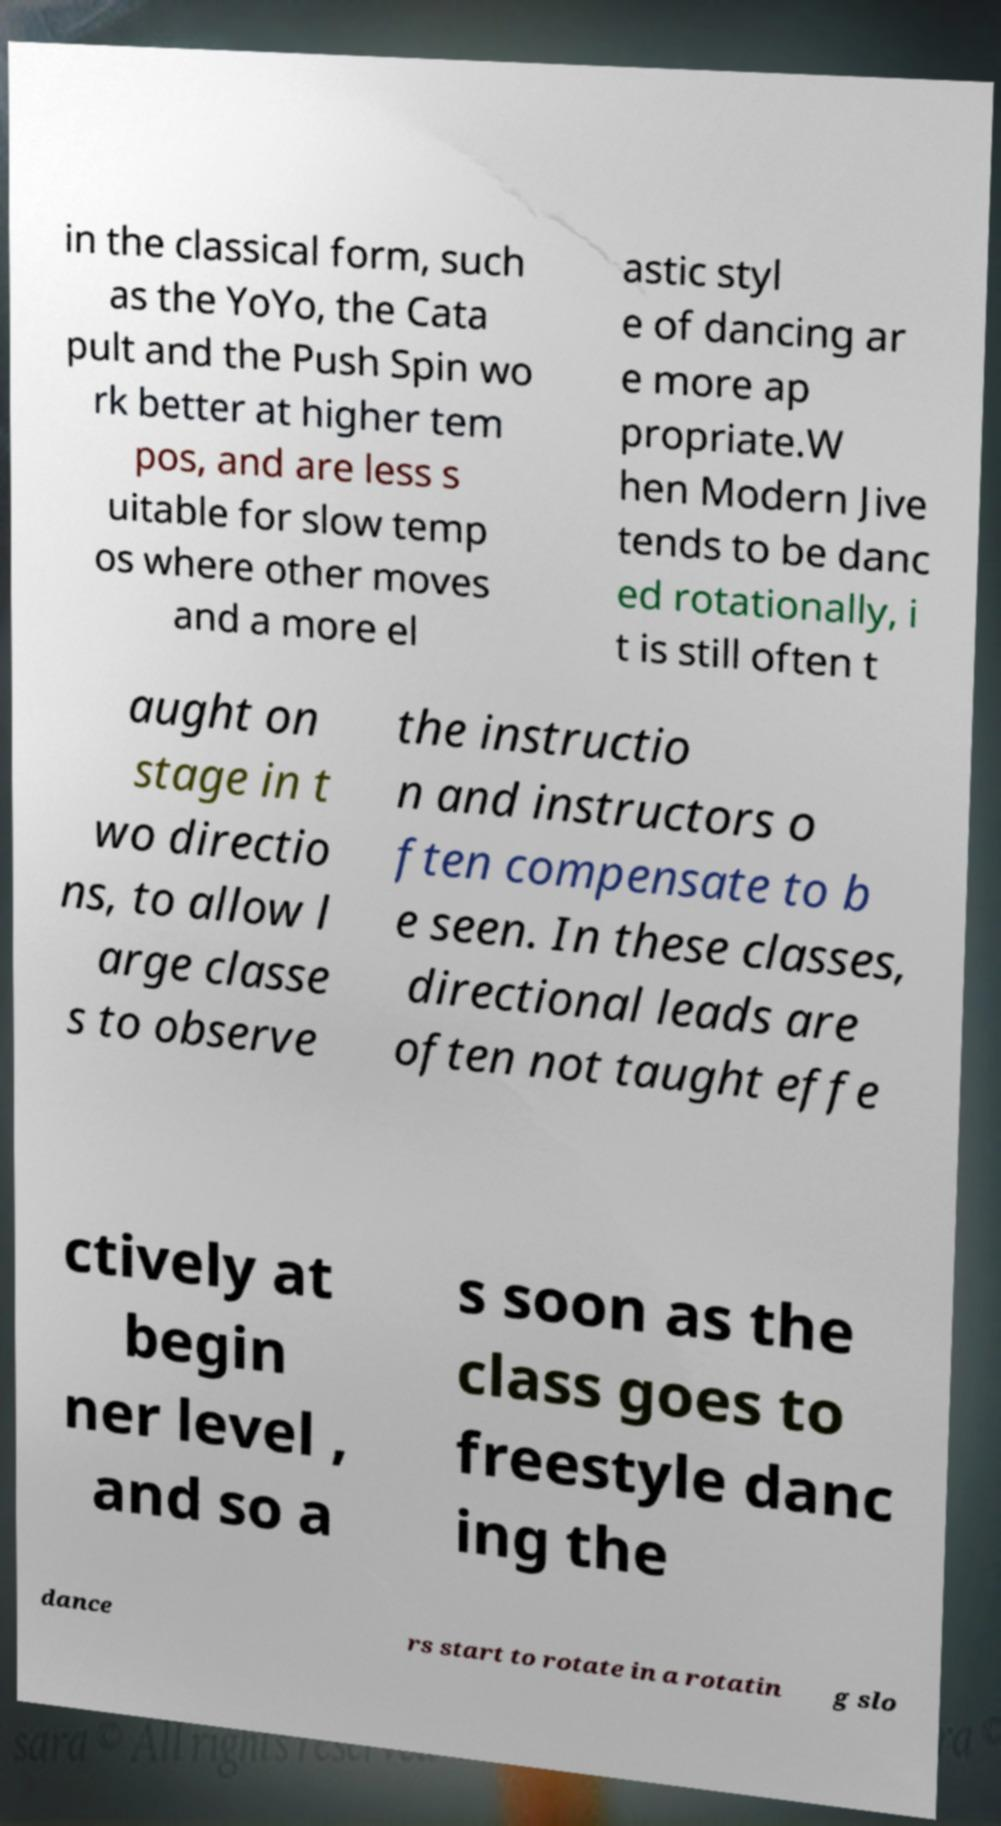Please identify and transcribe the text found in this image. in the classical form, such as the YoYo, the Cata pult and the Push Spin wo rk better at higher tem pos, and are less s uitable for slow temp os where other moves and a more el astic styl e of dancing ar e more ap propriate.W hen Modern Jive tends to be danc ed rotationally, i t is still often t aught on stage in t wo directio ns, to allow l arge classe s to observe the instructio n and instructors o ften compensate to b e seen. In these classes, directional leads are often not taught effe ctively at begin ner level , and so a s soon as the class goes to freestyle danc ing the dance rs start to rotate in a rotatin g slo 